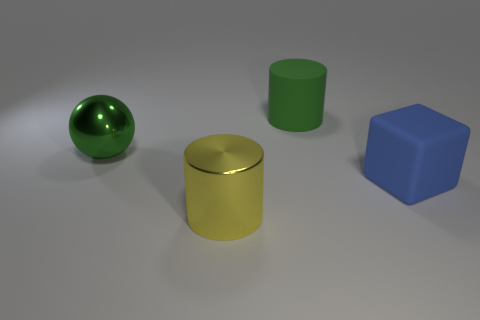Add 4 blue cylinders. How many objects exist? 8 Subtract all spheres. How many objects are left? 3 Add 3 big blue blocks. How many big blue blocks exist? 4 Subtract 0 cyan spheres. How many objects are left? 4 Subtract all blue balls. Subtract all big cylinders. How many objects are left? 2 Add 2 big green rubber objects. How many big green rubber objects are left? 3 